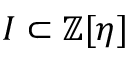Convert formula to latex. <formula><loc_0><loc_0><loc_500><loc_500>I \subset \mathbb { Z } [ \eta ]</formula> 